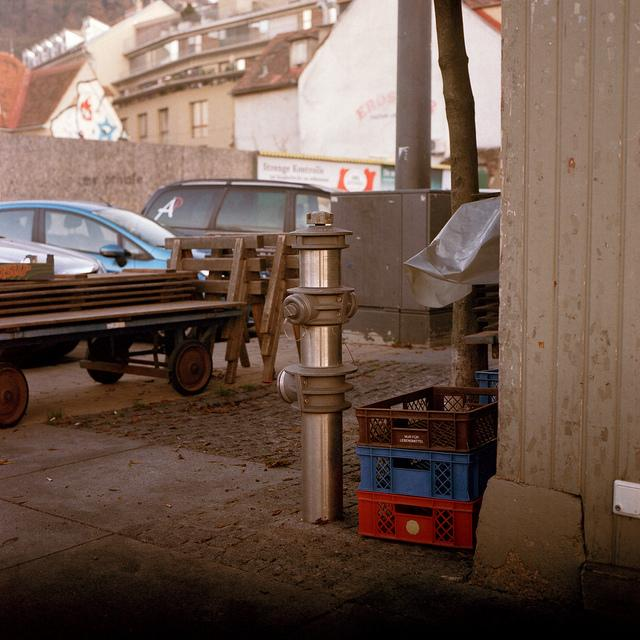What is stacked up near the wall on the right? crates 